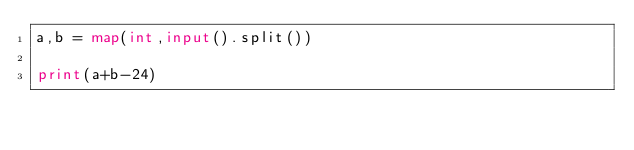Convert code to text. <code><loc_0><loc_0><loc_500><loc_500><_Python_>a,b = map(int,input().split())

print(a+b-24)</code> 